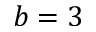<formula> <loc_0><loc_0><loc_500><loc_500>b = 3</formula> 